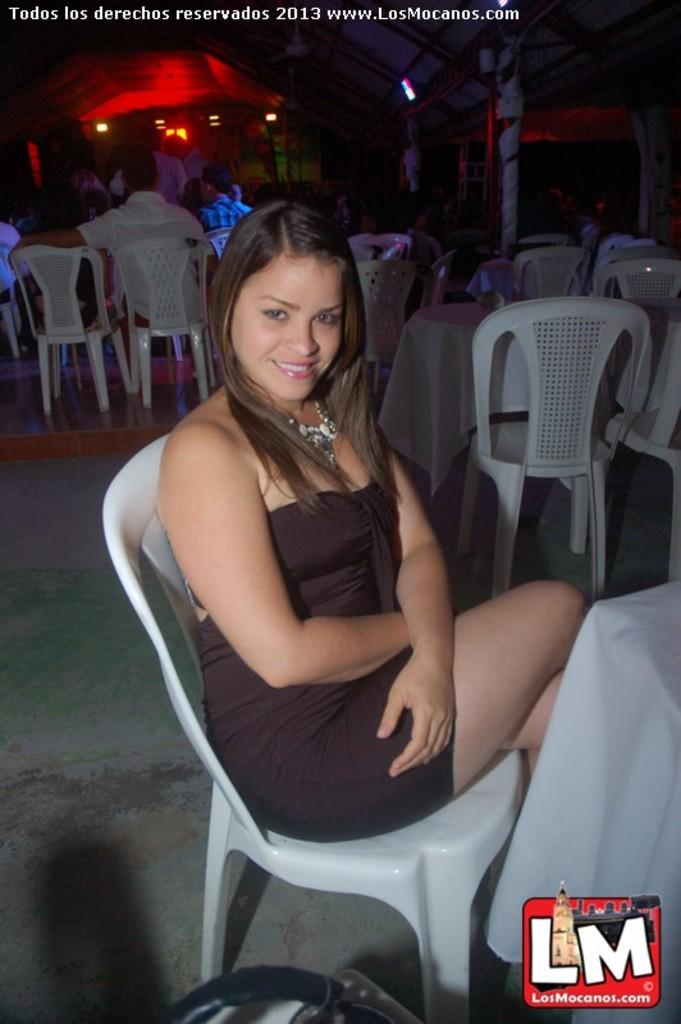What type of furniture is visible in the image? There are chairs and tables in the image. What color are the chairs and tables? The chairs and tables are white. Is there anyone sitting on a chair in the image? Yes, there is a woman sitting on a chair in the image. What can be seen in the background of the image? There is a red curtain in the background of the image. How many laborers are working in the image? There are no laborers present in the image. What type of rabbits can be seen playing in the image? There are no rabbits present in the image. 